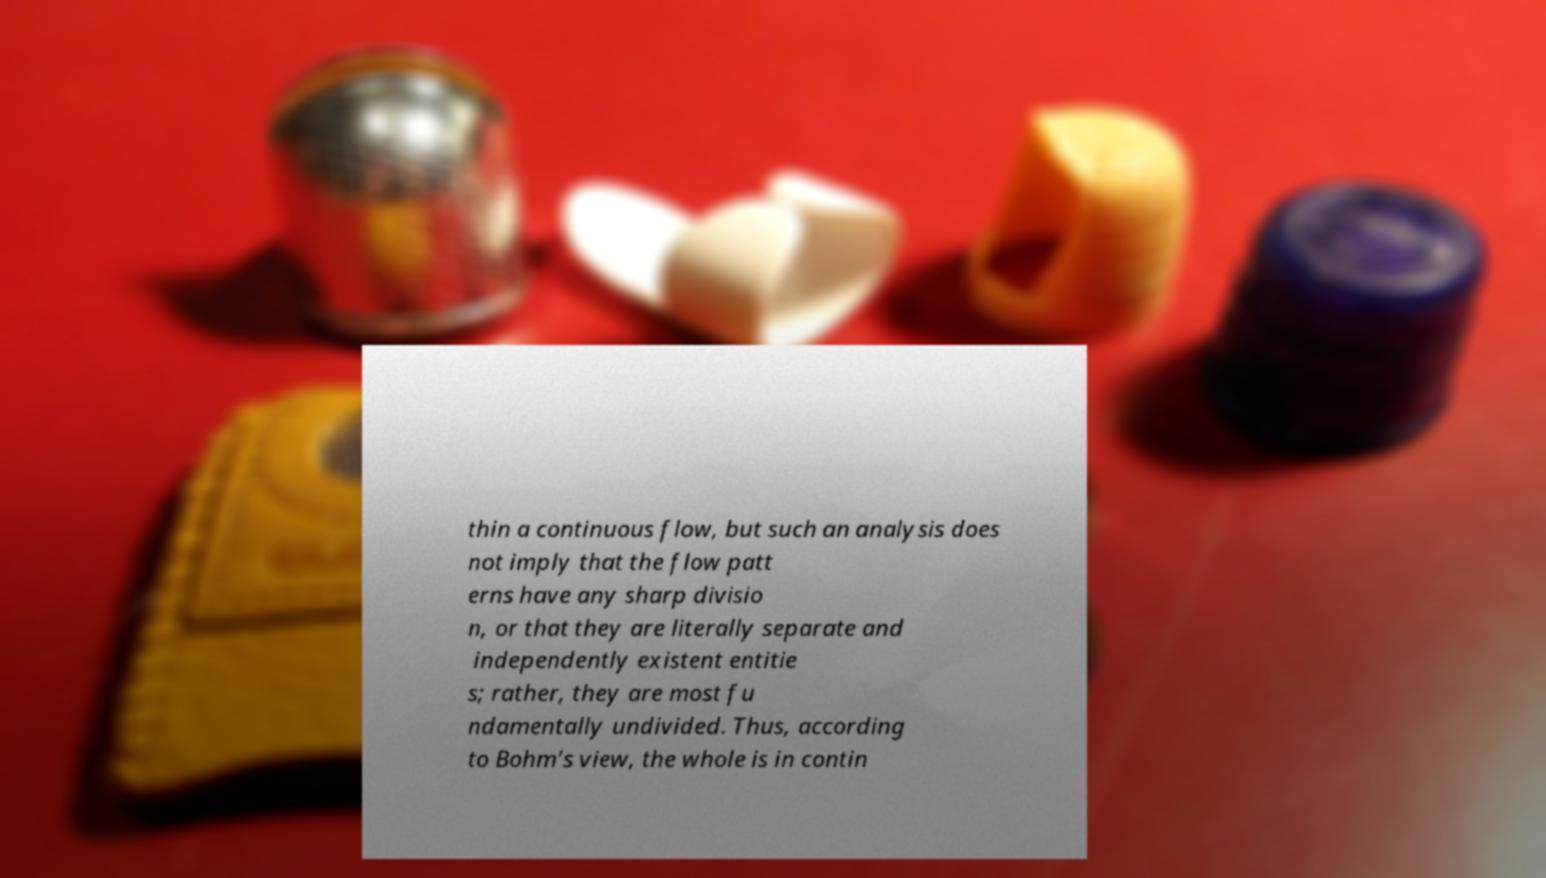Please read and relay the text visible in this image. What does it say? thin a continuous flow, but such an analysis does not imply that the flow patt erns have any sharp divisio n, or that they are literally separate and independently existent entitie s; rather, they are most fu ndamentally undivided. Thus, according to Bohm’s view, the whole is in contin 